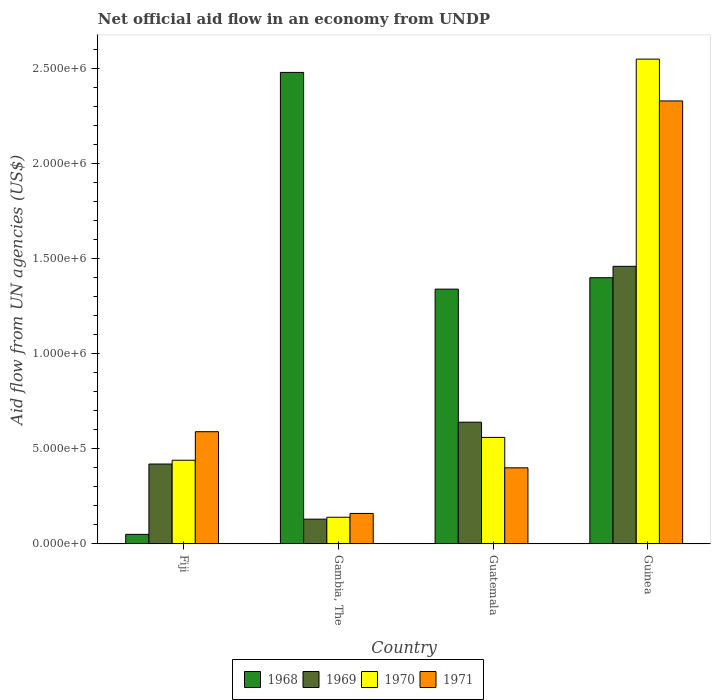How many bars are there on the 4th tick from the left?
Provide a short and direct response. 4. How many bars are there on the 2nd tick from the right?
Provide a short and direct response. 4. What is the label of the 2nd group of bars from the left?
Offer a terse response. Gambia, The. What is the net official aid flow in 1971 in Guinea?
Give a very brief answer. 2.33e+06. Across all countries, what is the maximum net official aid flow in 1970?
Make the answer very short. 2.55e+06. In which country was the net official aid flow in 1971 maximum?
Your response must be concise. Guinea. In which country was the net official aid flow in 1970 minimum?
Keep it short and to the point. Gambia, The. What is the total net official aid flow in 1971 in the graph?
Make the answer very short. 3.48e+06. What is the difference between the net official aid flow in 1971 in Fiji and that in Guinea?
Ensure brevity in your answer.  -1.74e+06. What is the average net official aid flow in 1970 per country?
Offer a very short reply. 9.22e+05. What is the difference between the net official aid flow of/in 1970 and net official aid flow of/in 1968 in Gambia, The?
Your answer should be compact. -2.34e+06. What is the ratio of the net official aid flow in 1970 in Gambia, The to that in Guatemala?
Make the answer very short. 0.25. What is the difference between the highest and the second highest net official aid flow in 1971?
Keep it short and to the point. 1.93e+06. What is the difference between the highest and the lowest net official aid flow in 1969?
Provide a succinct answer. 1.33e+06. Is the sum of the net official aid flow in 1970 in Fiji and Guatemala greater than the maximum net official aid flow in 1971 across all countries?
Your answer should be very brief. No. What does the 1st bar from the left in Gambia, The represents?
Offer a terse response. 1968. What does the 2nd bar from the right in Gambia, The represents?
Keep it short and to the point. 1970. Is it the case that in every country, the sum of the net official aid flow in 1969 and net official aid flow in 1971 is greater than the net official aid flow in 1970?
Ensure brevity in your answer.  Yes. Are all the bars in the graph horizontal?
Provide a succinct answer. No. How many countries are there in the graph?
Ensure brevity in your answer.  4. How many legend labels are there?
Offer a very short reply. 4. What is the title of the graph?
Make the answer very short. Net official aid flow in an economy from UNDP. Does "2014" appear as one of the legend labels in the graph?
Provide a short and direct response. No. What is the label or title of the X-axis?
Your answer should be compact. Country. What is the label or title of the Y-axis?
Provide a succinct answer. Aid flow from UN agencies (US$). What is the Aid flow from UN agencies (US$) in 1968 in Fiji?
Your response must be concise. 5.00e+04. What is the Aid flow from UN agencies (US$) of 1971 in Fiji?
Give a very brief answer. 5.90e+05. What is the Aid flow from UN agencies (US$) in 1968 in Gambia, The?
Provide a succinct answer. 2.48e+06. What is the Aid flow from UN agencies (US$) in 1969 in Gambia, The?
Provide a short and direct response. 1.30e+05. What is the Aid flow from UN agencies (US$) of 1968 in Guatemala?
Ensure brevity in your answer.  1.34e+06. What is the Aid flow from UN agencies (US$) in 1969 in Guatemala?
Make the answer very short. 6.40e+05. What is the Aid flow from UN agencies (US$) of 1970 in Guatemala?
Ensure brevity in your answer.  5.60e+05. What is the Aid flow from UN agencies (US$) of 1971 in Guatemala?
Keep it short and to the point. 4.00e+05. What is the Aid flow from UN agencies (US$) of 1968 in Guinea?
Ensure brevity in your answer.  1.40e+06. What is the Aid flow from UN agencies (US$) of 1969 in Guinea?
Make the answer very short. 1.46e+06. What is the Aid flow from UN agencies (US$) in 1970 in Guinea?
Provide a short and direct response. 2.55e+06. What is the Aid flow from UN agencies (US$) of 1971 in Guinea?
Offer a terse response. 2.33e+06. Across all countries, what is the maximum Aid flow from UN agencies (US$) of 1968?
Keep it short and to the point. 2.48e+06. Across all countries, what is the maximum Aid flow from UN agencies (US$) in 1969?
Ensure brevity in your answer.  1.46e+06. Across all countries, what is the maximum Aid flow from UN agencies (US$) of 1970?
Provide a short and direct response. 2.55e+06. Across all countries, what is the maximum Aid flow from UN agencies (US$) in 1971?
Your answer should be very brief. 2.33e+06. Across all countries, what is the minimum Aid flow from UN agencies (US$) of 1970?
Provide a short and direct response. 1.40e+05. Across all countries, what is the minimum Aid flow from UN agencies (US$) of 1971?
Keep it short and to the point. 1.60e+05. What is the total Aid flow from UN agencies (US$) in 1968 in the graph?
Give a very brief answer. 5.27e+06. What is the total Aid flow from UN agencies (US$) of 1969 in the graph?
Keep it short and to the point. 2.65e+06. What is the total Aid flow from UN agencies (US$) in 1970 in the graph?
Offer a terse response. 3.69e+06. What is the total Aid flow from UN agencies (US$) of 1971 in the graph?
Ensure brevity in your answer.  3.48e+06. What is the difference between the Aid flow from UN agencies (US$) in 1968 in Fiji and that in Gambia, The?
Your answer should be compact. -2.43e+06. What is the difference between the Aid flow from UN agencies (US$) of 1971 in Fiji and that in Gambia, The?
Provide a short and direct response. 4.30e+05. What is the difference between the Aid flow from UN agencies (US$) of 1968 in Fiji and that in Guatemala?
Offer a terse response. -1.29e+06. What is the difference between the Aid flow from UN agencies (US$) of 1971 in Fiji and that in Guatemala?
Provide a succinct answer. 1.90e+05. What is the difference between the Aid flow from UN agencies (US$) in 1968 in Fiji and that in Guinea?
Ensure brevity in your answer.  -1.35e+06. What is the difference between the Aid flow from UN agencies (US$) in 1969 in Fiji and that in Guinea?
Give a very brief answer. -1.04e+06. What is the difference between the Aid flow from UN agencies (US$) in 1970 in Fiji and that in Guinea?
Offer a terse response. -2.11e+06. What is the difference between the Aid flow from UN agencies (US$) in 1971 in Fiji and that in Guinea?
Your answer should be very brief. -1.74e+06. What is the difference between the Aid flow from UN agencies (US$) of 1968 in Gambia, The and that in Guatemala?
Ensure brevity in your answer.  1.14e+06. What is the difference between the Aid flow from UN agencies (US$) of 1969 in Gambia, The and that in Guatemala?
Your answer should be very brief. -5.10e+05. What is the difference between the Aid flow from UN agencies (US$) of 1970 in Gambia, The and that in Guatemala?
Give a very brief answer. -4.20e+05. What is the difference between the Aid flow from UN agencies (US$) in 1968 in Gambia, The and that in Guinea?
Provide a short and direct response. 1.08e+06. What is the difference between the Aid flow from UN agencies (US$) in 1969 in Gambia, The and that in Guinea?
Make the answer very short. -1.33e+06. What is the difference between the Aid flow from UN agencies (US$) of 1970 in Gambia, The and that in Guinea?
Offer a very short reply. -2.41e+06. What is the difference between the Aid flow from UN agencies (US$) of 1971 in Gambia, The and that in Guinea?
Give a very brief answer. -2.17e+06. What is the difference between the Aid flow from UN agencies (US$) of 1968 in Guatemala and that in Guinea?
Ensure brevity in your answer.  -6.00e+04. What is the difference between the Aid flow from UN agencies (US$) in 1969 in Guatemala and that in Guinea?
Offer a terse response. -8.20e+05. What is the difference between the Aid flow from UN agencies (US$) of 1970 in Guatemala and that in Guinea?
Your response must be concise. -1.99e+06. What is the difference between the Aid flow from UN agencies (US$) in 1971 in Guatemala and that in Guinea?
Make the answer very short. -1.93e+06. What is the difference between the Aid flow from UN agencies (US$) in 1968 in Fiji and the Aid flow from UN agencies (US$) in 1969 in Gambia, The?
Your answer should be very brief. -8.00e+04. What is the difference between the Aid flow from UN agencies (US$) of 1968 in Fiji and the Aid flow from UN agencies (US$) of 1970 in Gambia, The?
Your answer should be very brief. -9.00e+04. What is the difference between the Aid flow from UN agencies (US$) of 1969 in Fiji and the Aid flow from UN agencies (US$) of 1970 in Gambia, The?
Offer a very short reply. 2.80e+05. What is the difference between the Aid flow from UN agencies (US$) in 1969 in Fiji and the Aid flow from UN agencies (US$) in 1971 in Gambia, The?
Your response must be concise. 2.60e+05. What is the difference between the Aid flow from UN agencies (US$) of 1968 in Fiji and the Aid flow from UN agencies (US$) of 1969 in Guatemala?
Your response must be concise. -5.90e+05. What is the difference between the Aid flow from UN agencies (US$) in 1968 in Fiji and the Aid flow from UN agencies (US$) in 1970 in Guatemala?
Ensure brevity in your answer.  -5.10e+05. What is the difference between the Aid flow from UN agencies (US$) of 1968 in Fiji and the Aid flow from UN agencies (US$) of 1971 in Guatemala?
Provide a short and direct response. -3.50e+05. What is the difference between the Aid flow from UN agencies (US$) in 1969 in Fiji and the Aid flow from UN agencies (US$) in 1970 in Guatemala?
Provide a short and direct response. -1.40e+05. What is the difference between the Aid flow from UN agencies (US$) of 1969 in Fiji and the Aid flow from UN agencies (US$) of 1971 in Guatemala?
Keep it short and to the point. 2.00e+04. What is the difference between the Aid flow from UN agencies (US$) of 1970 in Fiji and the Aid flow from UN agencies (US$) of 1971 in Guatemala?
Offer a terse response. 4.00e+04. What is the difference between the Aid flow from UN agencies (US$) in 1968 in Fiji and the Aid flow from UN agencies (US$) in 1969 in Guinea?
Make the answer very short. -1.41e+06. What is the difference between the Aid flow from UN agencies (US$) of 1968 in Fiji and the Aid flow from UN agencies (US$) of 1970 in Guinea?
Provide a short and direct response. -2.50e+06. What is the difference between the Aid flow from UN agencies (US$) in 1968 in Fiji and the Aid flow from UN agencies (US$) in 1971 in Guinea?
Your answer should be very brief. -2.28e+06. What is the difference between the Aid flow from UN agencies (US$) of 1969 in Fiji and the Aid flow from UN agencies (US$) of 1970 in Guinea?
Ensure brevity in your answer.  -2.13e+06. What is the difference between the Aid flow from UN agencies (US$) in 1969 in Fiji and the Aid flow from UN agencies (US$) in 1971 in Guinea?
Give a very brief answer. -1.91e+06. What is the difference between the Aid flow from UN agencies (US$) of 1970 in Fiji and the Aid flow from UN agencies (US$) of 1971 in Guinea?
Your answer should be very brief. -1.89e+06. What is the difference between the Aid flow from UN agencies (US$) of 1968 in Gambia, The and the Aid flow from UN agencies (US$) of 1969 in Guatemala?
Offer a very short reply. 1.84e+06. What is the difference between the Aid flow from UN agencies (US$) of 1968 in Gambia, The and the Aid flow from UN agencies (US$) of 1970 in Guatemala?
Make the answer very short. 1.92e+06. What is the difference between the Aid flow from UN agencies (US$) of 1968 in Gambia, The and the Aid flow from UN agencies (US$) of 1971 in Guatemala?
Ensure brevity in your answer.  2.08e+06. What is the difference between the Aid flow from UN agencies (US$) of 1969 in Gambia, The and the Aid flow from UN agencies (US$) of 1970 in Guatemala?
Offer a very short reply. -4.30e+05. What is the difference between the Aid flow from UN agencies (US$) of 1969 in Gambia, The and the Aid flow from UN agencies (US$) of 1971 in Guatemala?
Give a very brief answer. -2.70e+05. What is the difference between the Aid flow from UN agencies (US$) of 1968 in Gambia, The and the Aid flow from UN agencies (US$) of 1969 in Guinea?
Make the answer very short. 1.02e+06. What is the difference between the Aid flow from UN agencies (US$) of 1968 in Gambia, The and the Aid flow from UN agencies (US$) of 1970 in Guinea?
Your response must be concise. -7.00e+04. What is the difference between the Aid flow from UN agencies (US$) of 1969 in Gambia, The and the Aid flow from UN agencies (US$) of 1970 in Guinea?
Keep it short and to the point. -2.42e+06. What is the difference between the Aid flow from UN agencies (US$) of 1969 in Gambia, The and the Aid flow from UN agencies (US$) of 1971 in Guinea?
Give a very brief answer. -2.20e+06. What is the difference between the Aid flow from UN agencies (US$) of 1970 in Gambia, The and the Aid flow from UN agencies (US$) of 1971 in Guinea?
Make the answer very short. -2.19e+06. What is the difference between the Aid flow from UN agencies (US$) of 1968 in Guatemala and the Aid flow from UN agencies (US$) of 1969 in Guinea?
Make the answer very short. -1.20e+05. What is the difference between the Aid flow from UN agencies (US$) in 1968 in Guatemala and the Aid flow from UN agencies (US$) in 1970 in Guinea?
Offer a terse response. -1.21e+06. What is the difference between the Aid flow from UN agencies (US$) of 1968 in Guatemala and the Aid flow from UN agencies (US$) of 1971 in Guinea?
Your answer should be very brief. -9.90e+05. What is the difference between the Aid flow from UN agencies (US$) in 1969 in Guatemala and the Aid flow from UN agencies (US$) in 1970 in Guinea?
Offer a very short reply. -1.91e+06. What is the difference between the Aid flow from UN agencies (US$) of 1969 in Guatemala and the Aid flow from UN agencies (US$) of 1971 in Guinea?
Your answer should be very brief. -1.69e+06. What is the difference between the Aid flow from UN agencies (US$) of 1970 in Guatemala and the Aid flow from UN agencies (US$) of 1971 in Guinea?
Your answer should be compact. -1.77e+06. What is the average Aid flow from UN agencies (US$) in 1968 per country?
Provide a succinct answer. 1.32e+06. What is the average Aid flow from UN agencies (US$) in 1969 per country?
Provide a succinct answer. 6.62e+05. What is the average Aid flow from UN agencies (US$) in 1970 per country?
Offer a very short reply. 9.22e+05. What is the average Aid flow from UN agencies (US$) of 1971 per country?
Your answer should be compact. 8.70e+05. What is the difference between the Aid flow from UN agencies (US$) of 1968 and Aid flow from UN agencies (US$) of 1969 in Fiji?
Offer a terse response. -3.70e+05. What is the difference between the Aid flow from UN agencies (US$) of 1968 and Aid flow from UN agencies (US$) of 1970 in Fiji?
Your response must be concise. -3.90e+05. What is the difference between the Aid flow from UN agencies (US$) in 1968 and Aid flow from UN agencies (US$) in 1971 in Fiji?
Offer a terse response. -5.40e+05. What is the difference between the Aid flow from UN agencies (US$) in 1969 and Aid flow from UN agencies (US$) in 1970 in Fiji?
Provide a short and direct response. -2.00e+04. What is the difference between the Aid flow from UN agencies (US$) of 1970 and Aid flow from UN agencies (US$) of 1971 in Fiji?
Keep it short and to the point. -1.50e+05. What is the difference between the Aid flow from UN agencies (US$) of 1968 and Aid flow from UN agencies (US$) of 1969 in Gambia, The?
Your answer should be very brief. 2.35e+06. What is the difference between the Aid flow from UN agencies (US$) of 1968 and Aid flow from UN agencies (US$) of 1970 in Gambia, The?
Your answer should be very brief. 2.34e+06. What is the difference between the Aid flow from UN agencies (US$) in 1968 and Aid flow from UN agencies (US$) in 1971 in Gambia, The?
Your answer should be compact. 2.32e+06. What is the difference between the Aid flow from UN agencies (US$) of 1968 and Aid flow from UN agencies (US$) of 1969 in Guatemala?
Your response must be concise. 7.00e+05. What is the difference between the Aid flow from UN agencies (US$) of 1968 and Aid flow from UN agencies (US$) of 1970 in Guatemala?
Keep it short and to the point. 7.80e+05. What is the difference between the Aid flow from UN agencies (US$) in 1968 and Aid flow from UN agencies (US$) in 1971 in Guatemala?
Make the answer very short. 9.40e+05. What is the difference between the Aid flow from UN agencies (US$) in 1969 and Aid flow from UN agencies (US$) in 1970 in Guatemala?
Offer a very short reply. 8.00e+04. What is the difference between the Aid flow from UN agencies (US$) in 1969 and Aid flow from UN agencies (US$) in 1971 in Guatemala?
Offer a very short reply. 2.40e+05. What is the difference between the Aid flow from UN agencies (US$) of 1970 and Aid flow from UN agencies (US$) of 1971 in Guatemala?
Make the answer very short. 1.60e+05. What is the difference between the Aid flow from UN agencies (US$) of 1968 and Aid flow from UN agencies (US$) of 1969 in Guinea?
Give a very brief answer. -6.00e+04. What is the difference between the Aid flow from UN agencies (US$) in 1968 and Aid flow from UN agencies (US$) in 1970 in Guinea?
Keep it short and to the point. -1.15e+06. What is the difference between the Aid flow from UN agencies (US$) in 1968 and Aid flow from UN agencies (US$) in 1971 in Guinea?
Provide a short and direct response. -9.30e+05. What is the difference between the Aid flow from UN agencies (US$) in 1969 and Aid flow from UN agencies (US$) in 1970 in Guinea?
Your answer should be compact. -1.09e+06. What is the difference between the Aid flow from UN agencies (US$) of 1969 and Aid flow from UN agencies (US$) of 1971 in Guinea?
Provide a short and direct response. -8.70e+05. What is the ratio of the Aid flow from UN agencies (US$) in 1968 in Fiji to that in Gambia, The?
Your answer should be compact. 0.02. What is the ratio of the Aid flow from UN agencies (US$) in 1969 in Fiji to that in Gambia, The?
Make the answer very short. 3.23. What is the ratio of the Aid flow from UN agencies (US$) in 1970 in Fiji to that in Gambia, The?
Provide a short and direct response. 3.14. What is the ratio of the Aid flow from UN agencies (US$) of 1971 in Fiji to that in Gambia, The?
Make the answer very short. 3.69. What is the ratio of the Aid flow from UN agencies (US$) of 1968 in Fiji to that in Guatemala?
Provide a short and direct response. 0.04. What is the ratio of the Aid flow from UN agencies (US$) in 1969 in Fiji to that in Guatemala?
Your answer should be very brief. 0.66. What is the ratio of the Aid flow from UN agencies (US$) in 1970 in Fiji to that in Guatemala?
Offer a very short reply. 0.79. What is the ratio of the Aid flow from UN agencies (US$) of 1971 in Fiji to that in Guatemala?
Your answer should be very brief. 1.48. What is the ratio of the Aid flow from UN agencies (US$) in 1968 in Fiji to that in Guinea?
Offer a terse response. 0.04. What is the ratio of the Aid flow from UN agencies (US$) in 1969 in Fiji to that in Guinea?
Your answer should be compact. 0.29. What is the ratio of the Aid flow from UN agencies (US$) of 1970 in Fiji to that in Guinea?
Your response must be concise. 0.17. What is the ratio of the Aid flow from UN agencies (US$) of 1971 in Fiji to that in Guinea?
Your response must be concise. 0.25. What is the ratio of the Aid flow from UN agencies (US$) of 1968 in Gambia, The to that in Guatemala?
Provide a short and direct response. 1.85. What is the ratio of the Aid flow from UN agencies (US$) in 1969 in Gambia, The to that in Guatemala?
Keep it short and to the point. 0.2. What is the ratio of the Aid flow from UN agencies (US$) of 1971 in Gambia, The to that in Guatemala?
Keep it short and to the point. 0.4. What is the ratio of the Aid flow from UN agencies (US$) of 1968 in Gambia, The to that in Guinea?
Ensure brevity in your answer.  1.77. What is the ratio of the Aid flow from UN agencies (US$) of 1969 in Gambia, The to that in Guinea?
Ensure brevity in your answer.  0.09. What is the ratio of the Aid flow from UN agencies (US$) in 1970 in Gambia, The to that in Guinea?
Provide a short and direct response. 0.05. What is the ratio of the Aid flow from UN agencies (US$) in 1971 in Gambia, The to that in Guinea?
Offer a very short reply. 0.07. What is the ratio of the Aid flow from UN agencies (US$) of 1968 in Guatemala to that in Guinea?
Offer a very short reply. 0.96. What is the ratio of the Aid flow from UN agencies (US$) of 1969 in Guatemala to that in Guinea?
Provide a succinct answer. 0.44. What is the ratio of the Aid flow from UN agencies (US$) of 1970 in Guatemala to that in Guinea?
Keep it short and to the point. 0.22. What is the ratio of the Aid flow from UN agencies (US$) in 1971 in Guatemala to that in Guinea?
Make the answer very short. 0.17. What is the difference between the highest and the second highest Aid flow from UN agencies (US$) of 1968?
Your response must be concise. 1.08e+06. What is the difference between the highest and the second highest Aid flow from UN agencies (US$) in 1969?
Make the answer very short. 8.20e+05. What is the difference between the highest and the second highest Aid flow from UN agencies (US$) of 1970?
Give a very brief answer. 1.99e+06. What is the difference between the highest and the second highest Aid flow from UN agencies (US$) of 1971?
Provide a short and direct response. 1.74e+06. What is the difference between the highest and the lowest Aid flow from UN agencies (US$) of 1968?
Offer a very short reply. 2.43e+06. What is the difference between the highest and the lowest Aid flow from UN agencies (US$) of 1969?
Ensure brevity in your answer.  1.33e+06. What is the difference between the highest and the lowest Aid flow from UN agencies (US$) in 1970?
Offer a terse response. 2.41e+06. What is the difference between the highest and the lowest Aid flow from UN agencies (US$) of 1971?
Your response must be concise. 2.17e+06. 